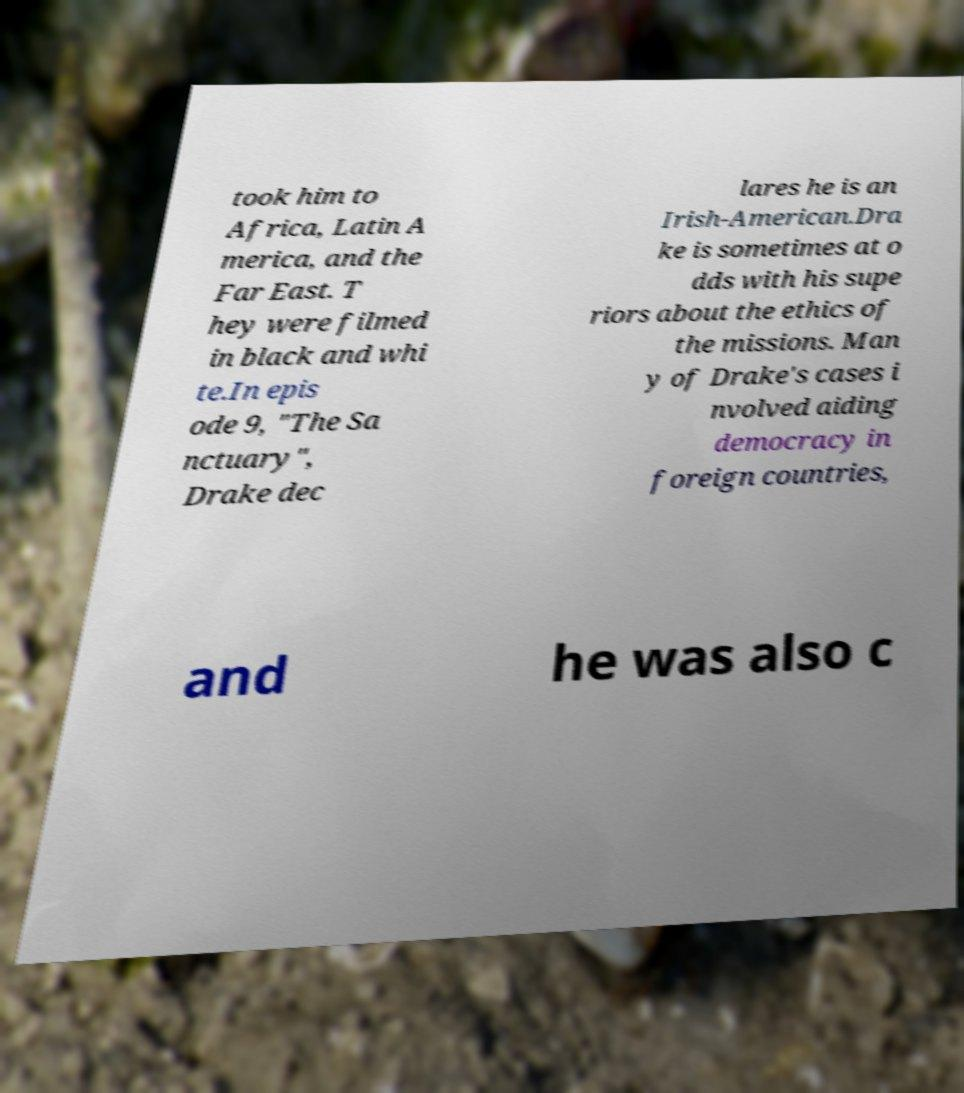Can you read and provide the text displayed in the image?This photo seems to have some interesting text. Can you extract and type it out for me? took him to Africa, Latin A merica, and the Far East. T hey were filmed in black and whi te.In epis ode 9, "The Sa nctuary", Drake dec lares he is an Irish-American.Dra ke is sometimes at o dds with his supe riors about the ethics of the missions. Man y of Drake's cases i nvolved aiding democracy in foreign countries, and he was also c 